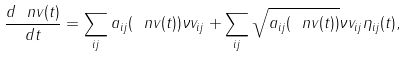Convert formula to latex. <formula><loc_0><loc_0><loc_500><loc_500>\frac { d \ n v ( t ) } { d t } = \sum _ { i j } a _ { i j } ( \ n v ( t ) ) \nu v _ { i j } + \sum _ { i j } \sqrt { a _ { i j } ( \ n v ( t ) ) } \nu v _ { i j } \eta _ { i j } ( t ) ,</formula> 